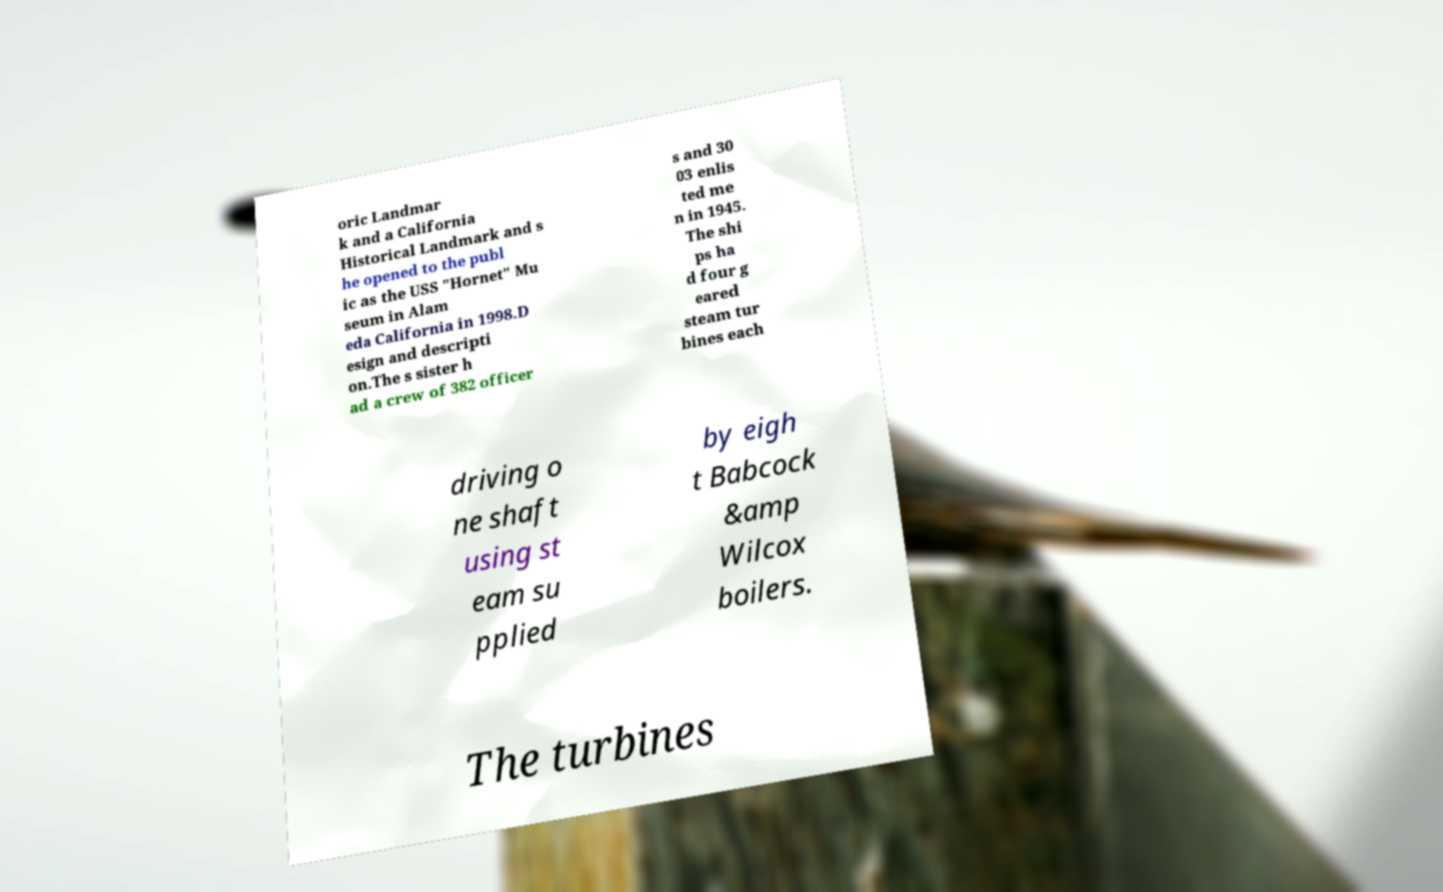What messages or text are displayed in this image? I need them in a readable, typed format. oric Landmar k and a California Historical Landmark and s he opened to the publ ic as the USS "Hornet" Mu seum in Alam eda California in 1998.D esign and descripti on.The s sister h ad a crew of 382 officer s and 30 03 enlis ted me n in 1945. The shi ps ha d four g eared steam tur bines each driving o ne shaft using st eam su pplied by eigh t Babcock &amp Wilcox boilers. The turbines 